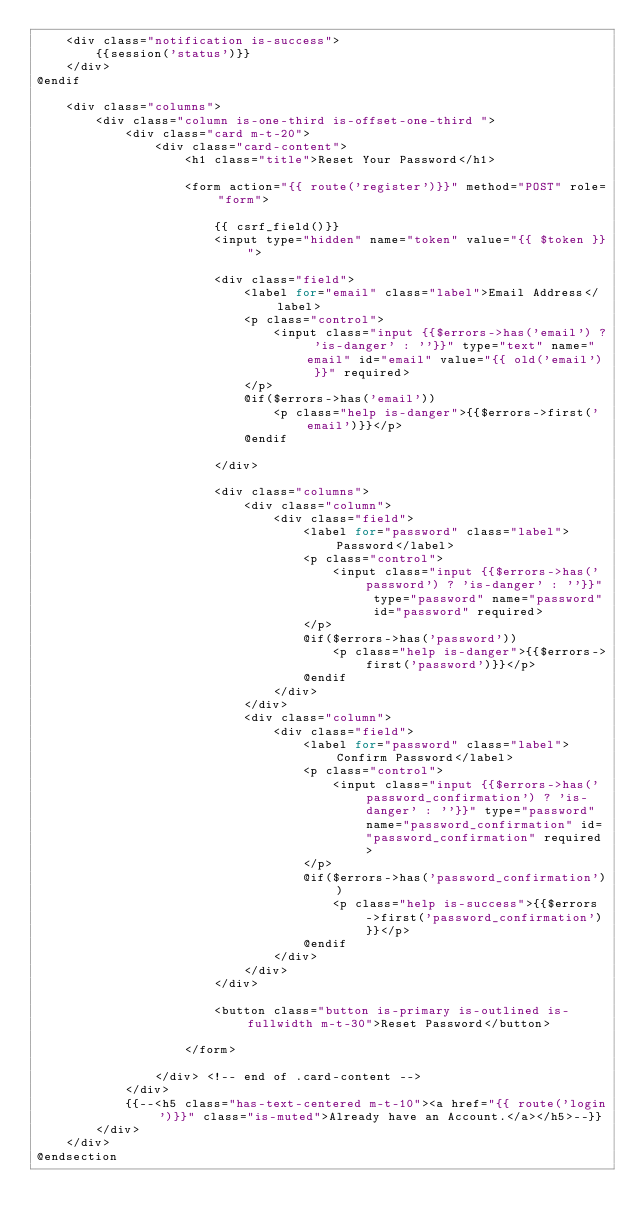Convert code to text. <code><loc_0><loc_0><loc_500><loc_500><_PHP_>    <div class="notification is-success">
        {{session('status')}}
    </div>
@endif

    <div class="columns">
        <div class="column is-one-third is-offset-one-third ">
            <div class="card m-t-20">
                <div class="card-content">
                    <h1 class="title">Reset Your Password</h1>

                    <form action="{{ route('register')}}" method="POST" role="form">

                        {{ csrf_field()}}
                        <input type="hidden" name="token" value="{{ $token }}">

                        <div class="field">
                            <label for="email" class="label">Email Address</label>
                            <p class="control">
                                <input class="input {{$errors->has('email') ? 'is-danger' : ''}}" type="text" name="email" id="email" value="{{ old('email') }}" required>
                            </p>
                            @if($errors->has('email'))
                                <p class="help is-danger">{{$errors->first('email')}}</p>
                            @endif

                        </div>

                        <div class="columns">
                            <div class="column">
                                <div class="field">
                                    <label for="password" class="label">Password</label>
                                    <p class="control">
                                        <input class="input {{$errors->has('password') ? 'is-danger' : ''}}" type="password" name="password" id="password" required>
                                    </p>
                                    @if($errors->has('password'))
                                        <p class="help is-danger">{{$errors->first('password')}}</p>
                                    @endif
                                </div>
                            </div>
                            <div class="column">
                                <div class="field">
                                    <label for="password" class="label">Confirm Password</label>
                                    <p class="control">
                                        <input class="input {{$errors->has('password_confirmation') ? 'is-danger' : ''}}" type="password" name="password_confirmation" id="password_confirmation" required>
                                    </p>
                                    @if($errors->has('password_confirmation'))
                                        <p class="help is-success">{{$errors->first('password_confirmation')}}</p>
                                    @endif
                                </div>
                            </div>
                        </div>

                        <button class="button is-primary is-outlined is-fullwidth m-t-30">Reset Password</button>

                    </form>

                </div> <!-- end of .card-content -->
            </div>
            {{--<h5 class="has-text-centered m-t-10"><a href="{{ route('login')}}" class="is-muted">Already have an Account.</a></h5>--}}
        </div>
    </div>
@endsection
</code> 